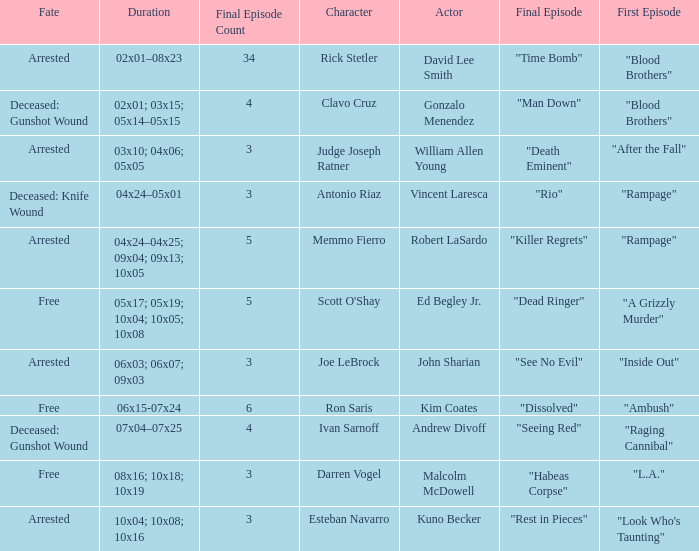What's the character with fate being deceased: knife wound Antonio Riaz. 